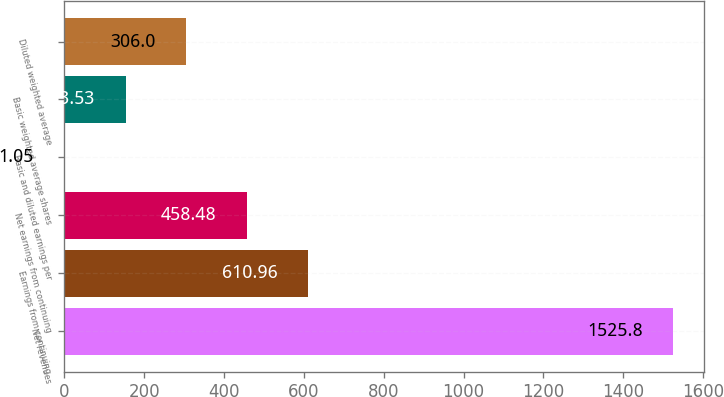<chart> <loc_0><loc_0><loc_500><loc_500><bar_chart><fcel>Net revenues<fcel>Earnings from continuing<fcel>Net earnings from continuing<fcel>Basic and diluted earnings per<fcel>Basic weighted average shares<fcel>Diluted weighted average<nl><fcel>1525.8<fcel>610.96<fcel>458.48<fcel>1.05<fcel>153.53<fcel>306<nl></chart> 